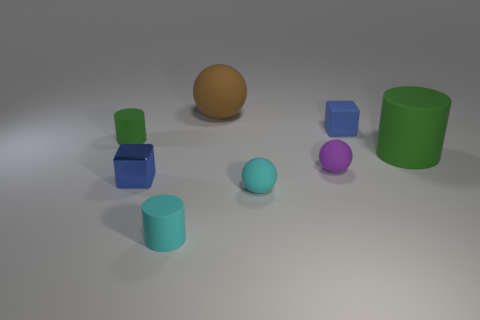Subtract all cyan cylinders. How many cylinders are left? 2 Subtract all blue blocks. How many green cylinders are left? 2 Subtract 1 cylinders. How many cylinders are left? 2 Add 1 green matte cylinders. How many objects exist? 9 Subtract all balls. How many objects are left? 5 Subtract all small blue rubber objects. Subtract all gray balls. How many objects are left? 7 Add 8 brown balls. How many brown balls are left? 9 Add 5 small green rubber cylinders. How many small green rubber cylinders exist? 6 Subtract 0 gray balls. How many objects are left? 8 